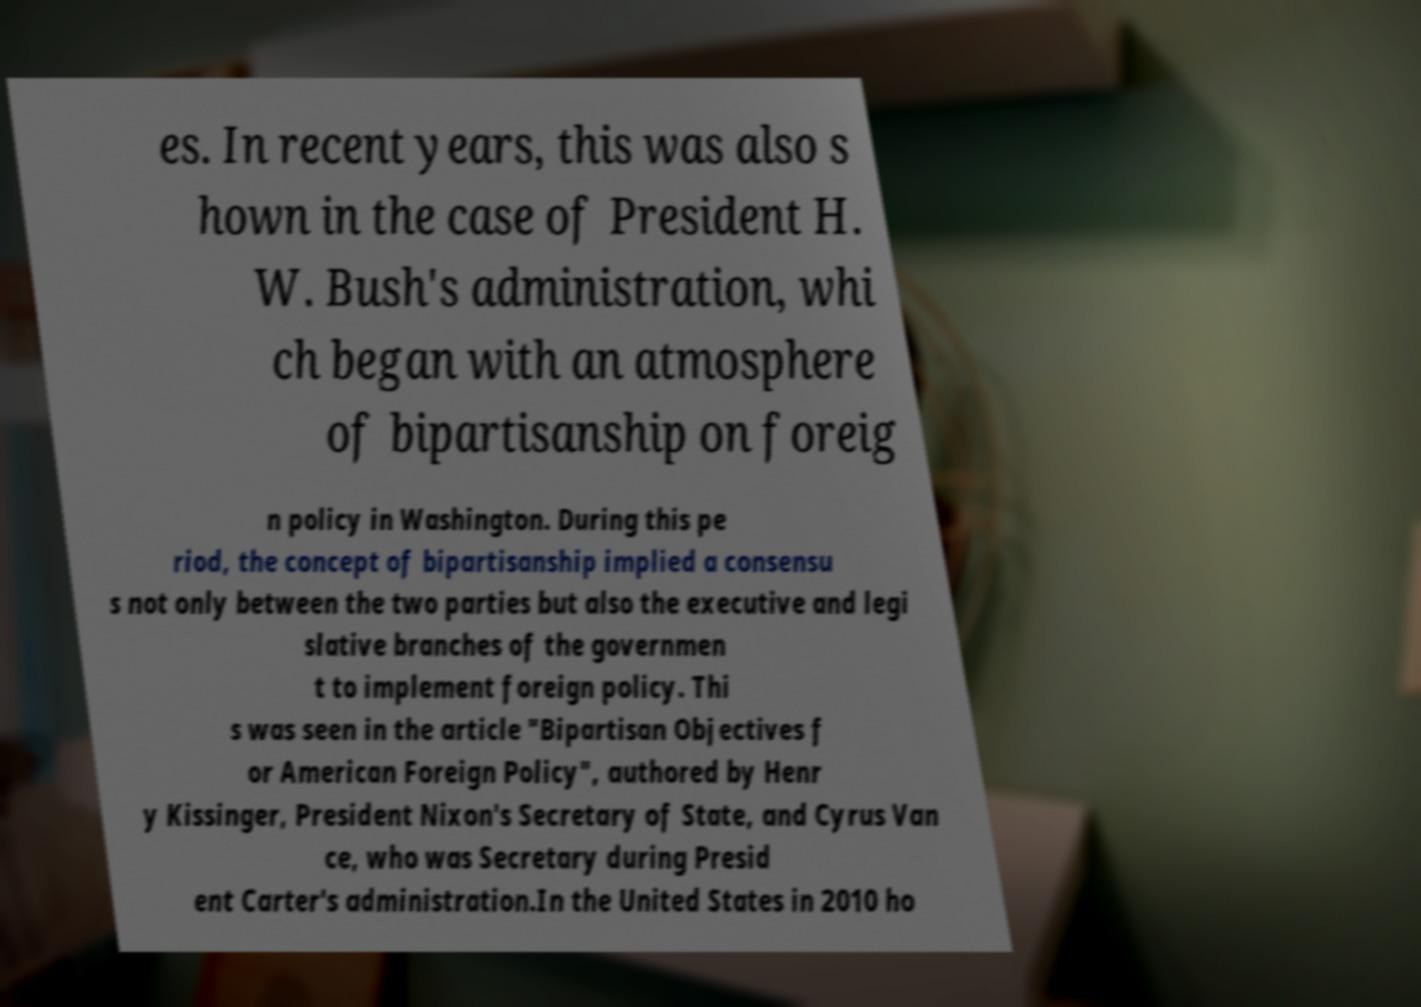What messages or text are displayed in this image? I need them in a readable, typed format. es. In recent years, this was also s hown in the case of President H. W. Bush's administration, whi ch began with an atmosphere of bipartisanship on foreig n policy in Washington. During this pe riod, the concept of bipartisanship implied a consensu s not only between the two parties but also the executive and legi slative branches of the governmen t to implement foreign policy. Thi s was seen in the article "Bipartisan Objectives f or American Foreign Policy", authored by Henr y Kissinger, President Nixon's Secretary of State, and Cyrus Van ce, who was Secretary during Presid ent Carter's administration.In the United States in 2010 ho 